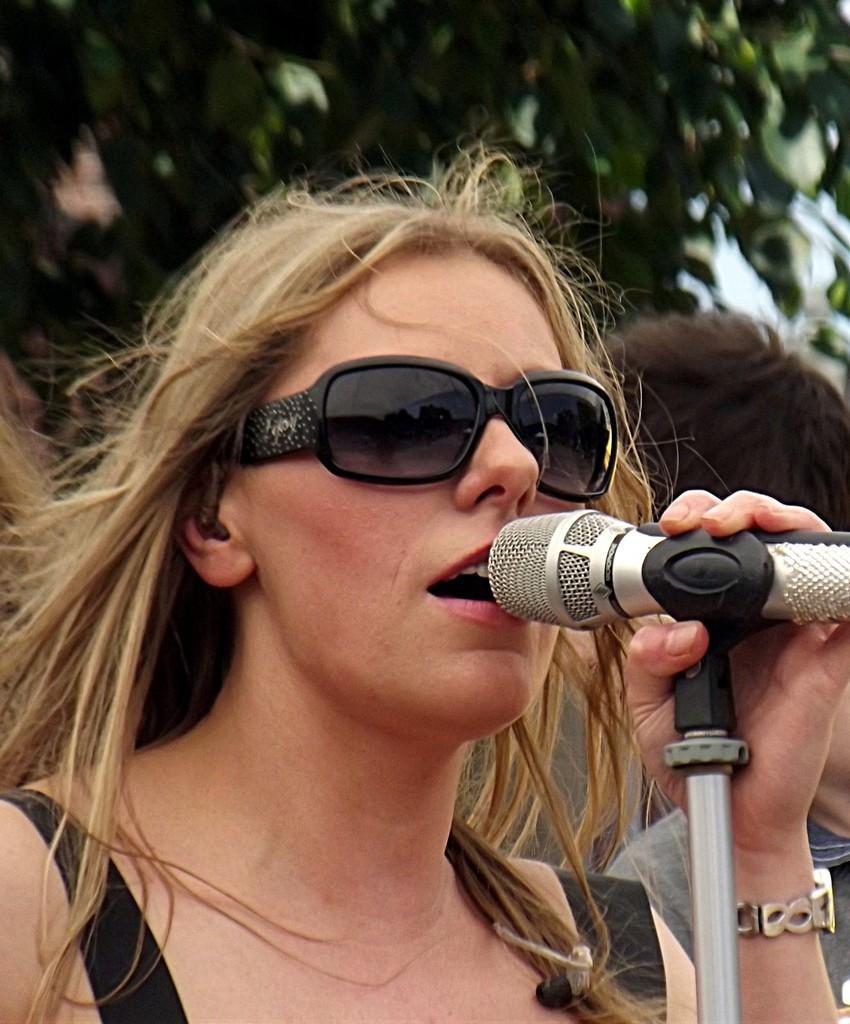Please provide a concise description of this image. this is the picture of a lady who is holding a mike in her left hand. 